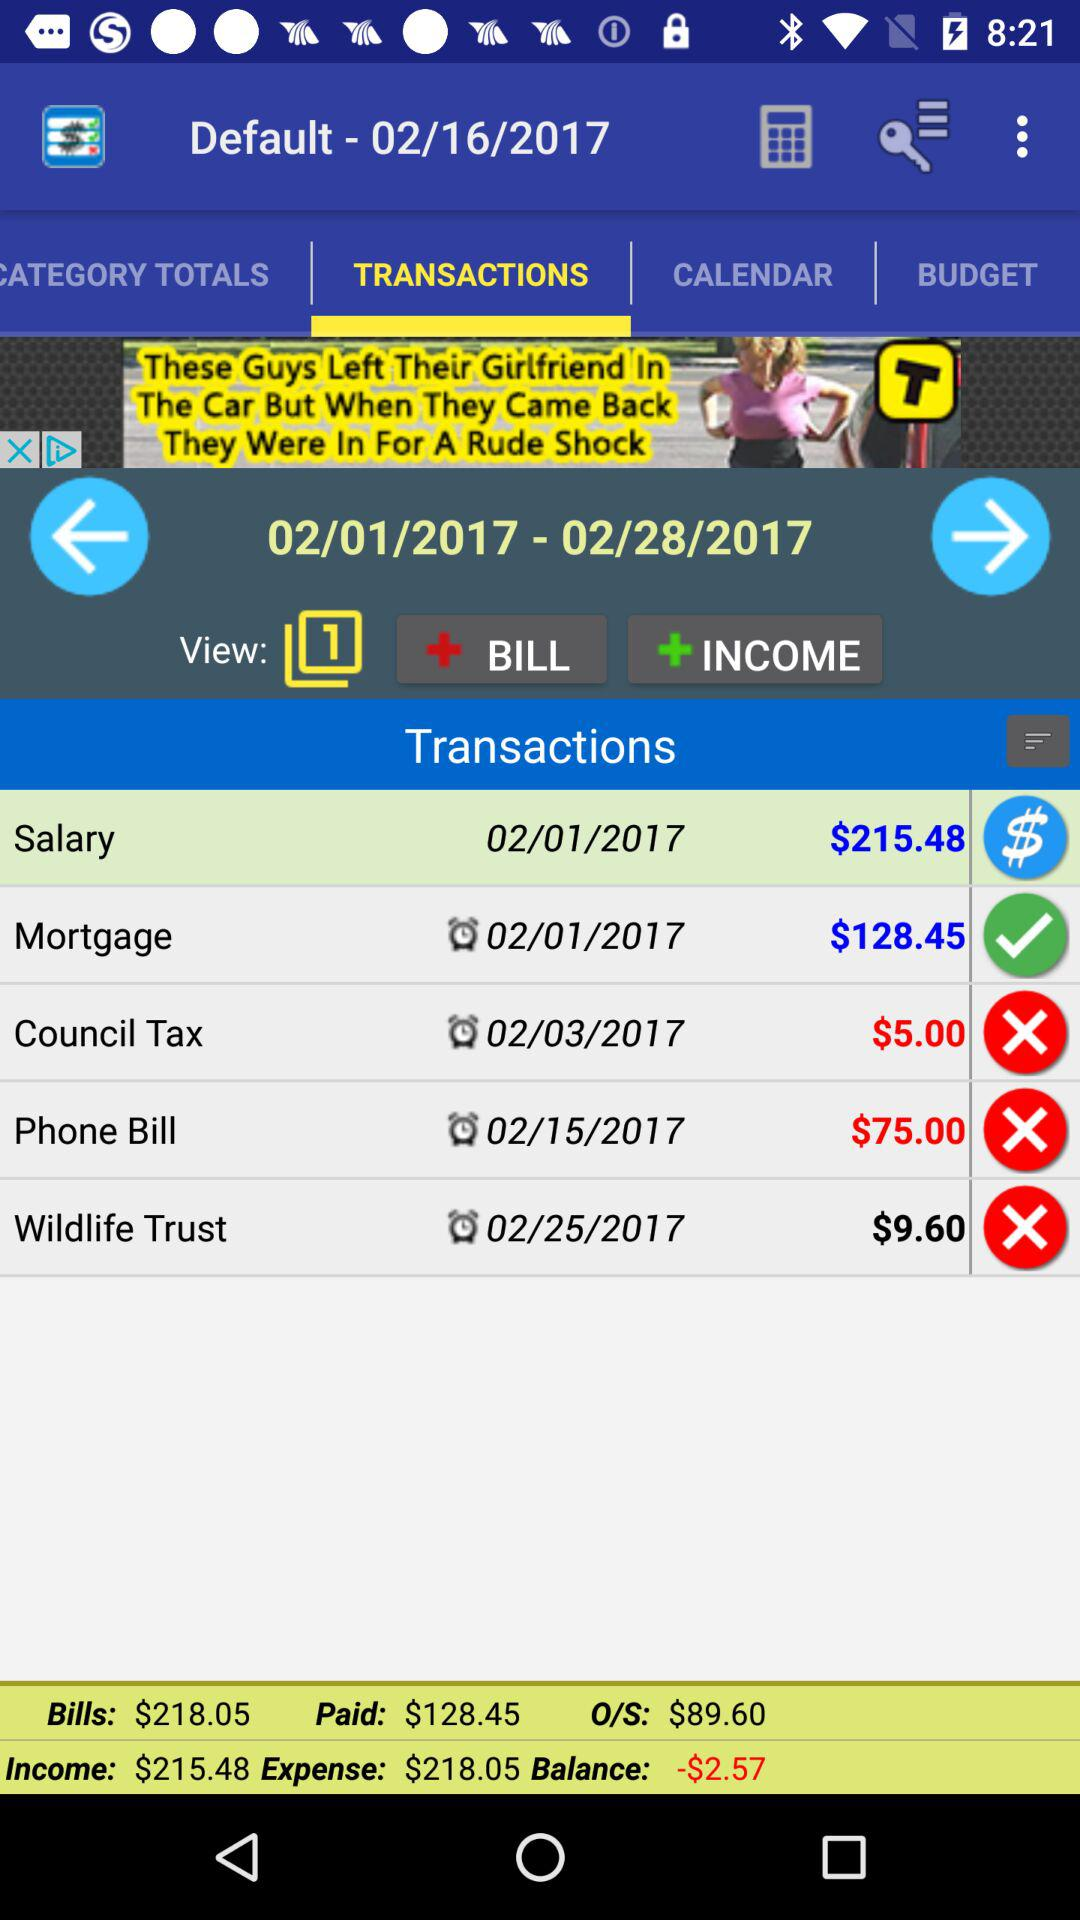What is the income? The income is $215.48. 